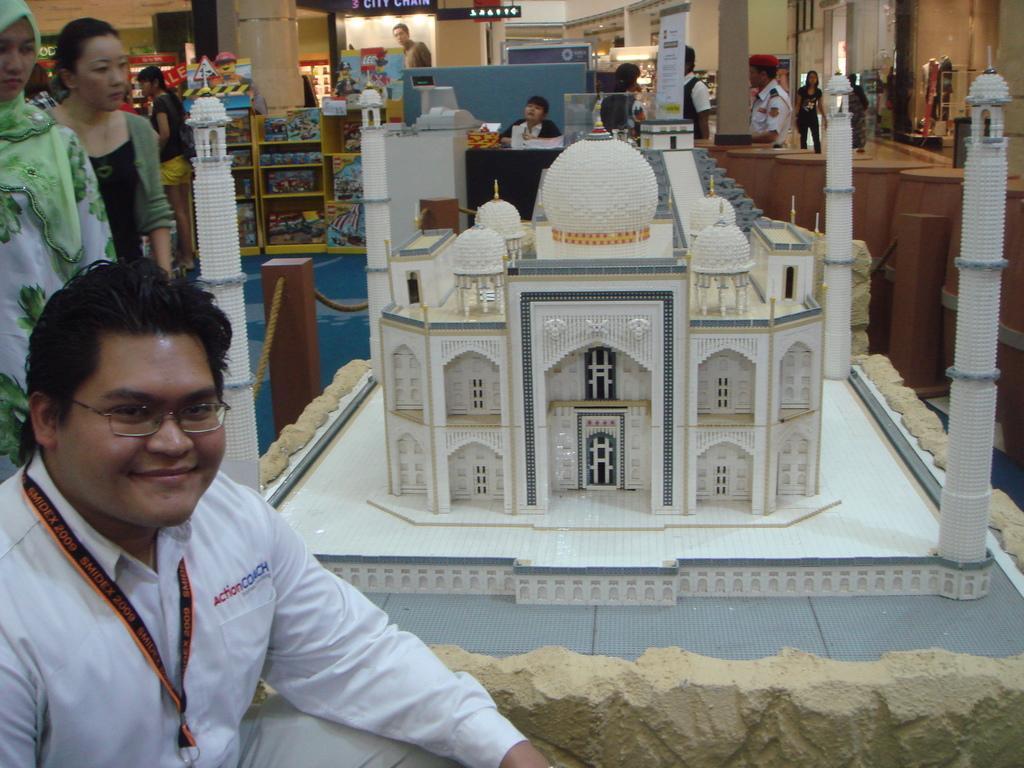How would you summarize this image in a sentence or two? In this image there are a few people standing and sitting on the floor, at the center of the image there is a depiction of taj mahal, behind that there is a lady sitting on the counter, beside her there are few objects arranged in a race, there are a few banners and some other objects. In the background there are few vendiman machines. 